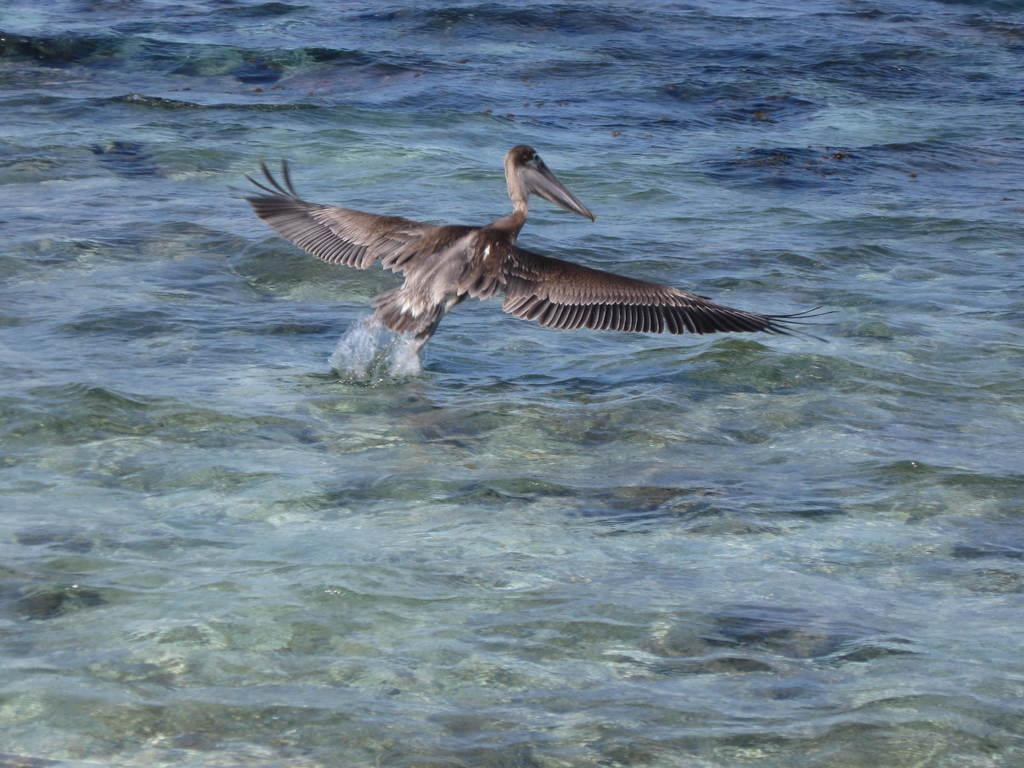What type of bird is in the image? There is a brown pelican in the image. What is the pelican doing in the image? The pelican is flying in the air. What can be seen below the pelican? There is water visible below the pelican. How many beds can be seen in the image? There are no beds present in the image; it features a brown pelican flying over water. 